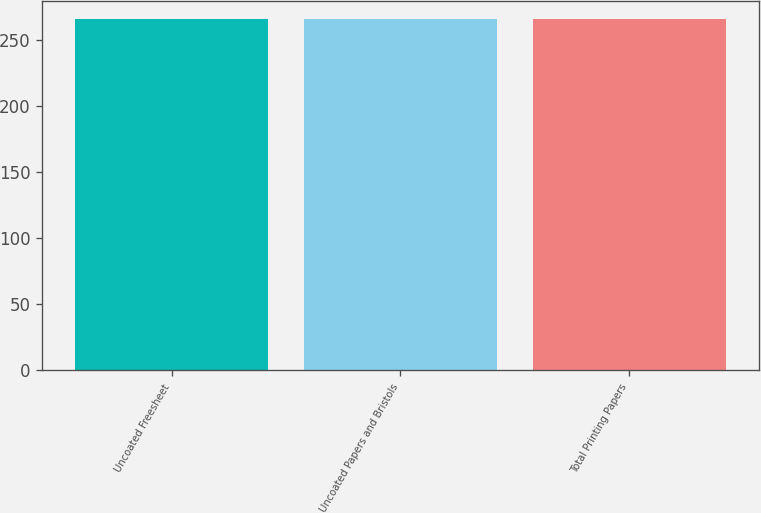<chart> <loc_0><loc_0><loc_500><loc_500><bar_chart><fcel>Uncoated Freesheet<fcel>Uncoated Papers and Bristols<fcel>Total Printing Papers<nl><fcel>266<fcel>266.1<fcel>266.2<nl></chart> 